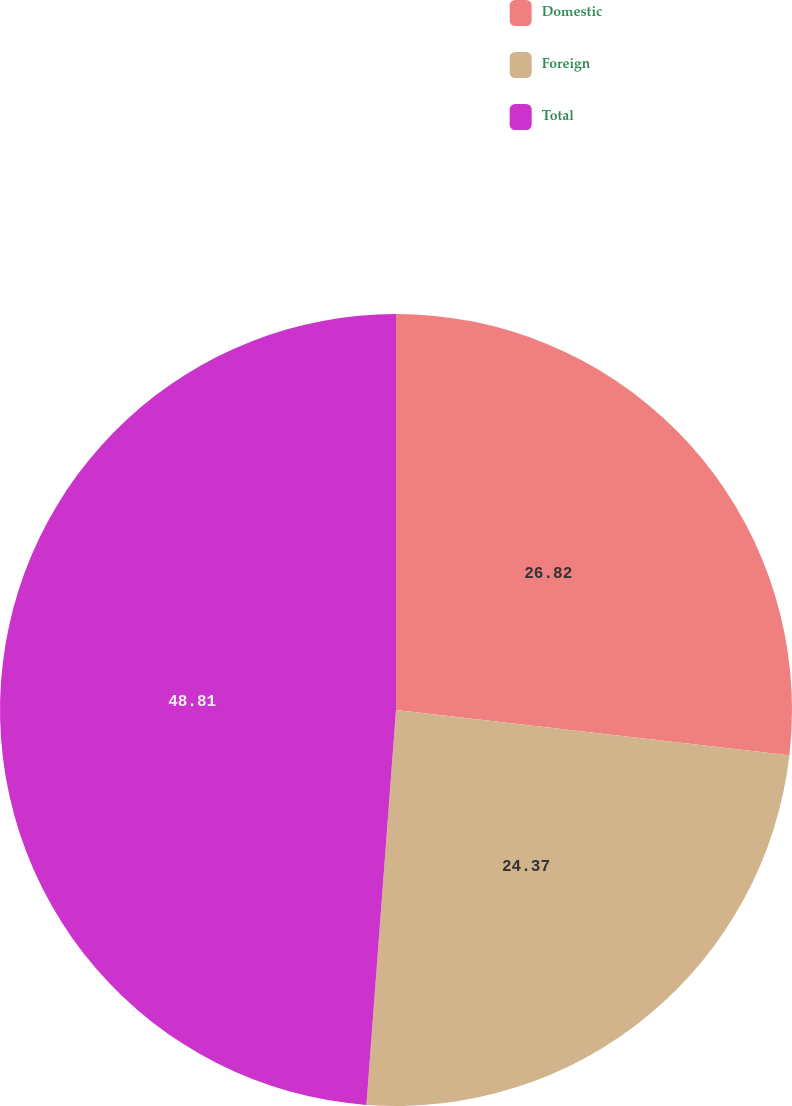<chart> <loc_0><loc_0><loc_500><loc_500><pie_chart><fcel>Domestic<fcel>Foreign<fcel>Total<nl><fcel>26.82%<fcel>24.37%<fcel>48.81%<nl></chart> 